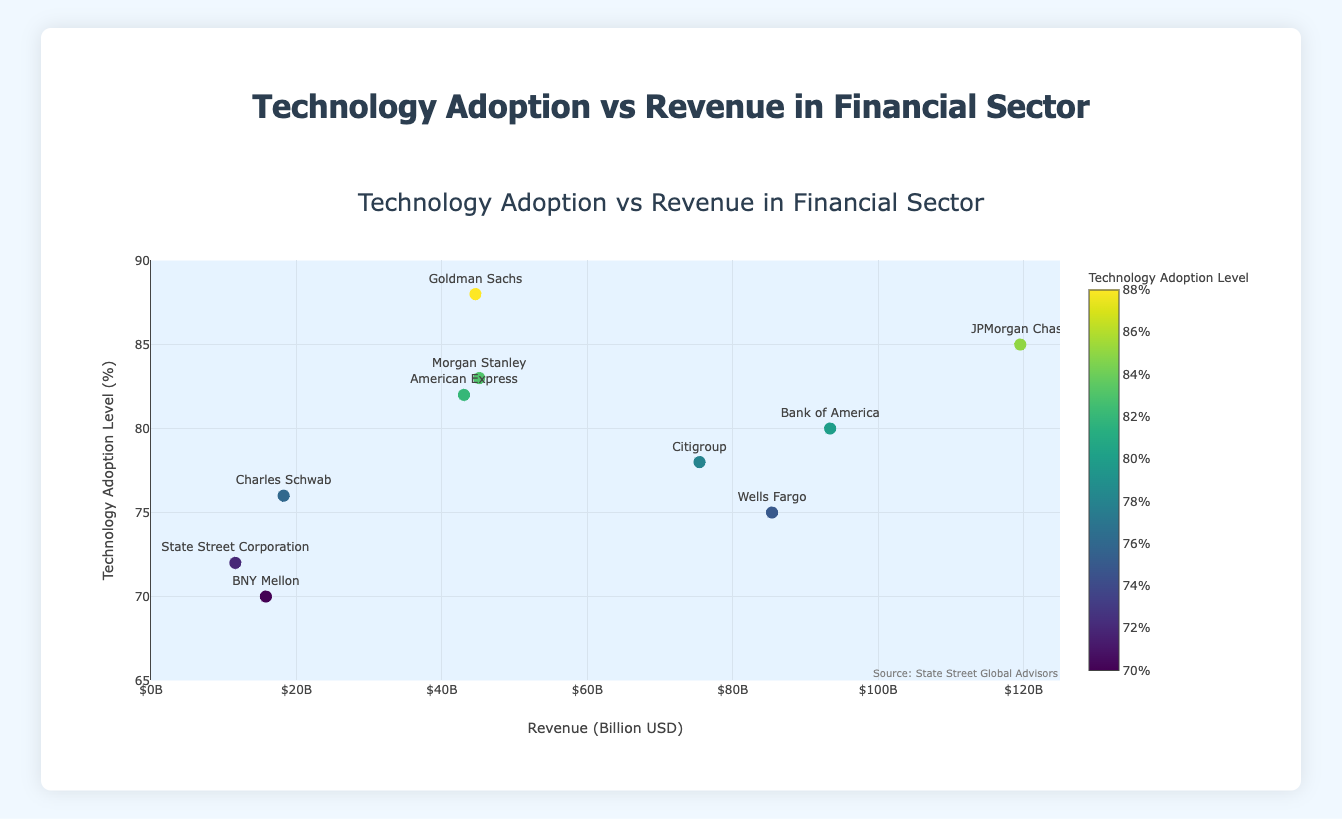What is the title of the figure? The title of the figure is displayed prominently at the top in larger font compared to the rest of the text. It reads "Technology Adoption vs Revenue in Financial Sector".
Answer: Technology Adoption vs Revenue in Financial Sector What is the revenue scale of the company with the highest technology adoption level? The company with the highest technology adoption level is Goldman Sachs with 88%. By reading its position on the x-axis and referring to the hover template that displays "$44.6B", it can be determined that its revenue is $44.6 billion.
Answer: $44.6 billion What is the technology adoption level of the company with the highest revenue? The company with the highest revenue is JPMorgan Chase which is observed as having the furthest point on the right on the x-axis corresponding to ~ $119.5B. The hover template confirms its technology adoption level to be 85%.
Answer: 85% Which company has the lowest technology adoption level and what is its revenue? The lowest technology adoption level is identified on the figure as the point lowest on the y-axis. The hover template for that point reveals the company to be BNY Mellon with 70% technology adoption level and also displays its revenue as $15.8B.
Answer: BNY Mellon, $15.8 billion Which company has a higher technology adoption level, Morgan Stanley or American Express? By comparing the positions on the y-axis of the dots corresponding to Morgan Stanley and American Express using their hover templates, Morgan Stanley is at 83%, and American Express is at 82%. Thus, Morgan Stanley has a higher technology adoption level.
Answer: Morgan Stanley What is the average technology adoption level of all companies? Add all technology adoption levels (85 + 80 + 75 + 78 + 88 + 83 + 70 + 72 + 76 + 82) = 789. Divide 789 by the number of companies, which is 10, resulting in an average technology adoption level of 78.9%.
Answer: 78.9% How many companies have a revenue above $50 billion? Locate the dots positioned to the right of the $50B mark on the x-axis. By using the hover templates: JPMorgan Chase, Bank of America, and Wells Fargo, indicate that three companies exceed $50 billion in revenue.
Answer: 3 Of the companies listed, which one falls closest to the median technology adoption level? First, list technology adoption levels in ascending order: 70, 72, 75, 76, 78, 80, 82, 83, 85, 88. Given ten numbers, the median is the average of the 5th and 6th values: (78 + 80) / 2 = 79. The company closest to this value is Citigroup with 78%.
Answer: Citigroup Are there any companies that have a technology adoption level greater than 80% but revenue less than $50 billion? If so, name them. Identify points with y-values above 80% and x-values to the left of the $50B mark. Those are: Goldman Sachs (88%, $44.6B) and Morgan Stanley (83%, $45.1B).
Answer: Goldman Sachs, Morgan Stanley 